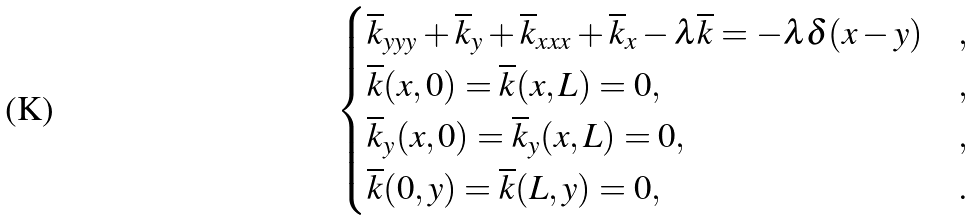Convert formula to latex. <formula><loc_0><loc_0><loc_500><loc_500>\begin{cases} \overline { k } _ { y y y } + \overline { k } _ { y } + \overline { k } _ { x x x } + \overline { k } _ { x } - \lambda \overline { k } = - \lambda \delta ( x - y ) & , \\ \overline { k } ( x , 0 ) = \overline { k } ( x , L ) = 0 , & , \\ \overline { k } _ { y } ( x , 0 ) = \overline { k } _ { y } ( x , L ) = 0 , & , \\ \overline { k } ( 0 , y ) = \overline { k } ( L , y ) = 0 , & . \end{cases}</formula> 